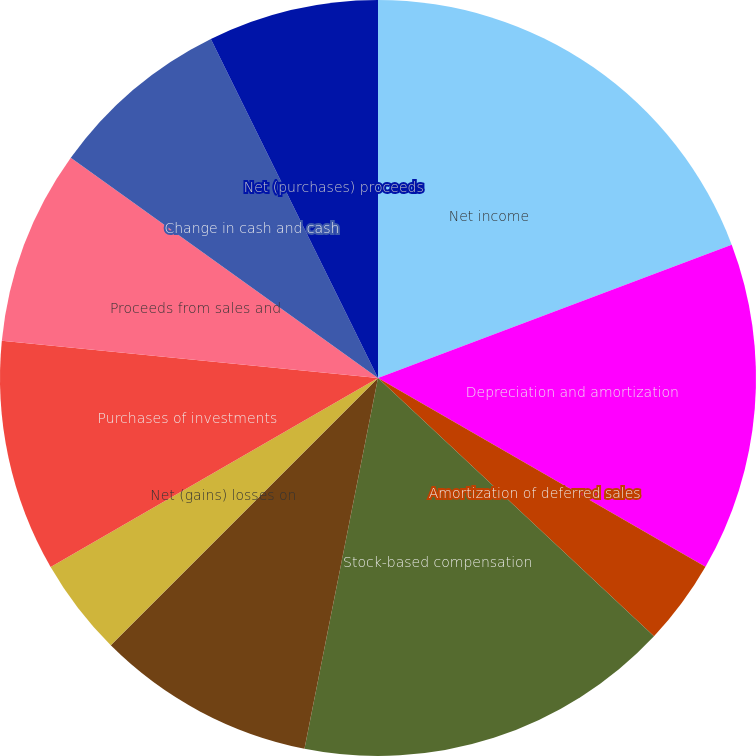<chart> <loc_0><loc_0><loc_500><loc_500><pie_chart><fcel>Net income<fcel>Depreciation and amortization<fcel>Amortization of deferred sales<fcel>Stock-based compensation<fcel>Deferred income tax expense<fcel>Net (gains) losses on<fcel>Purchases of investments<fcel>Proceeds from sales and<fcel>Change in cash and cash<fcel>Net (purchases) proceeds<nl><fcel>19.26%<fcel>14.06%<fcel>3.65%<fcel>16.14%<fcel>9.38%<fcel>4.17%<fcel>9.9%<fcel>8.33%<fcel>7.81%<fcel>7.29%<nl></chart> 